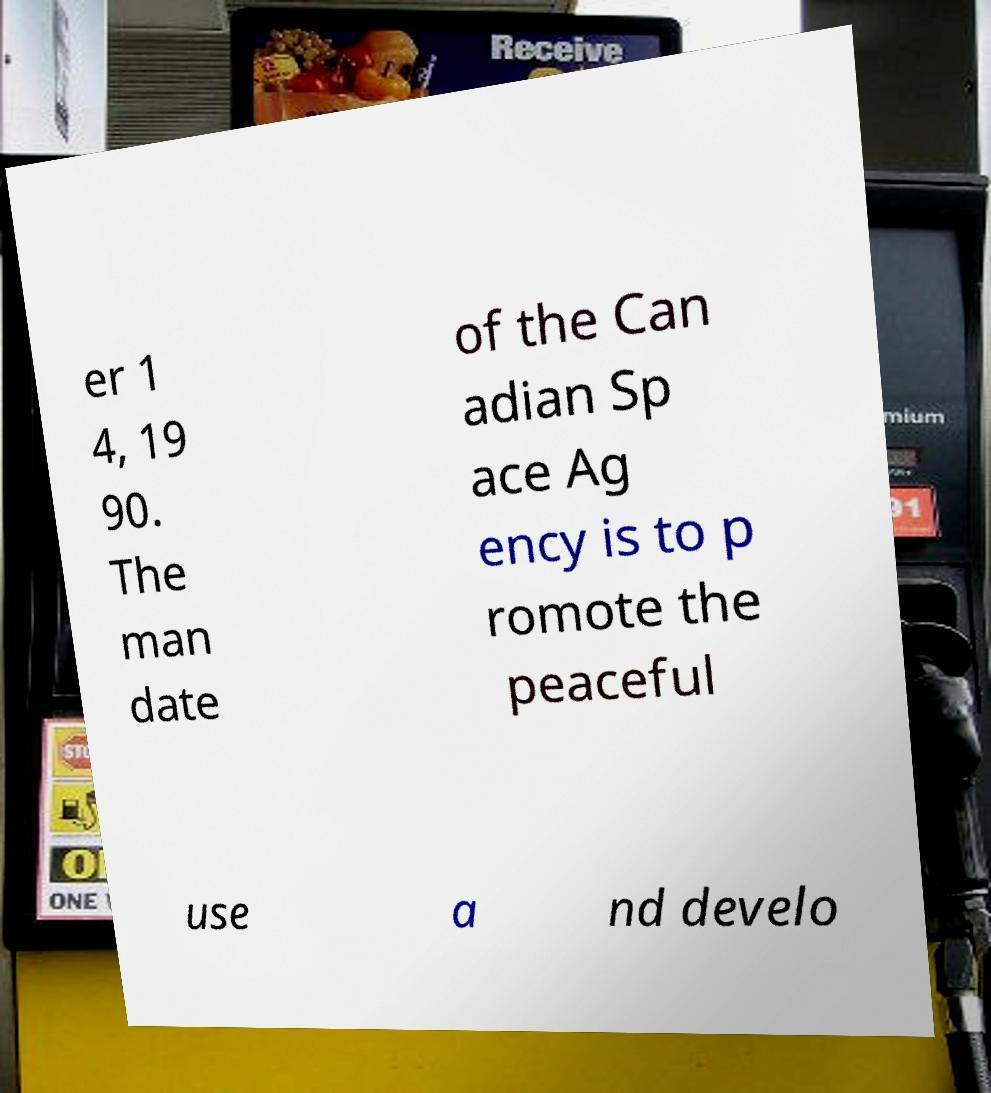Please read and relay the text visible in this image. What does it say? er 1 4, 19 90. The man date of the Can adian Sp ace Ag ency is to p romote the peaceful use a nd develo 